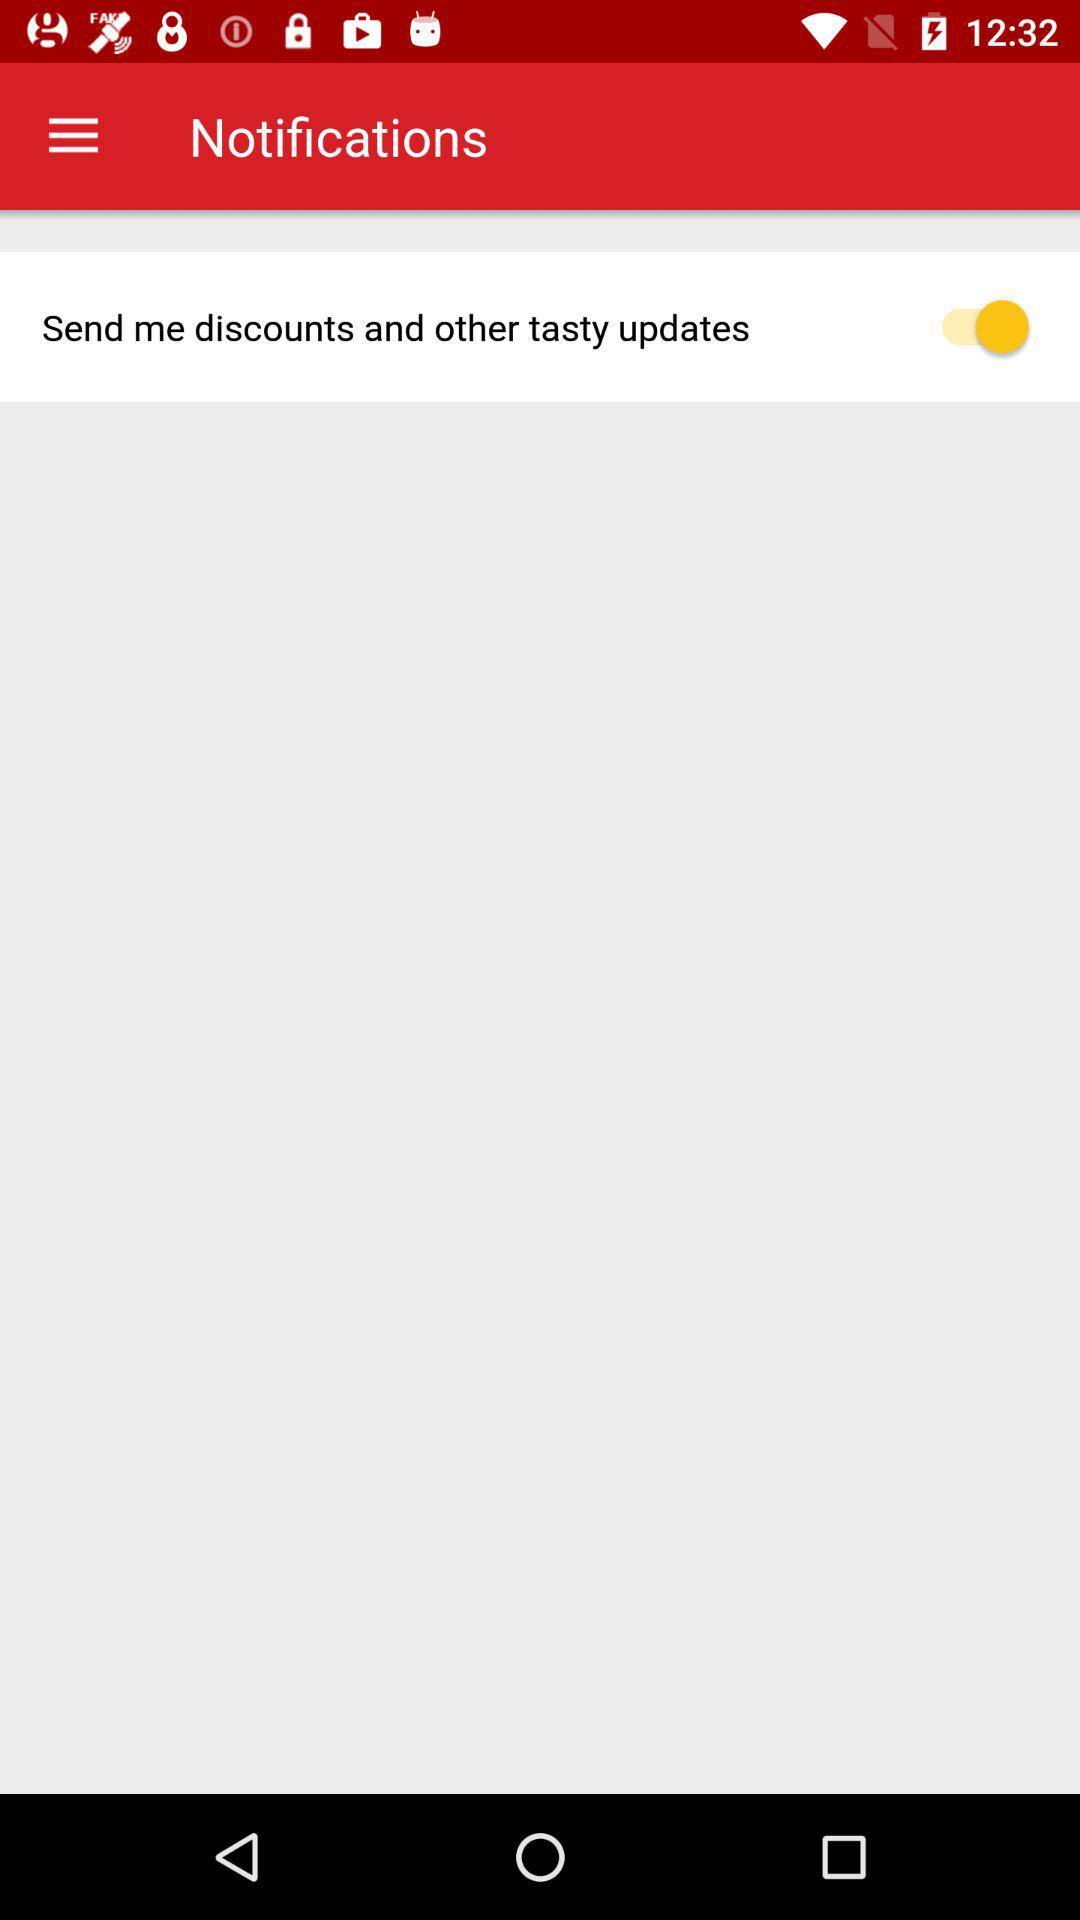What is the status of "Send me discounts and other tasty updates"? The status of "Send me discounts and other tasty updates" is "on". 